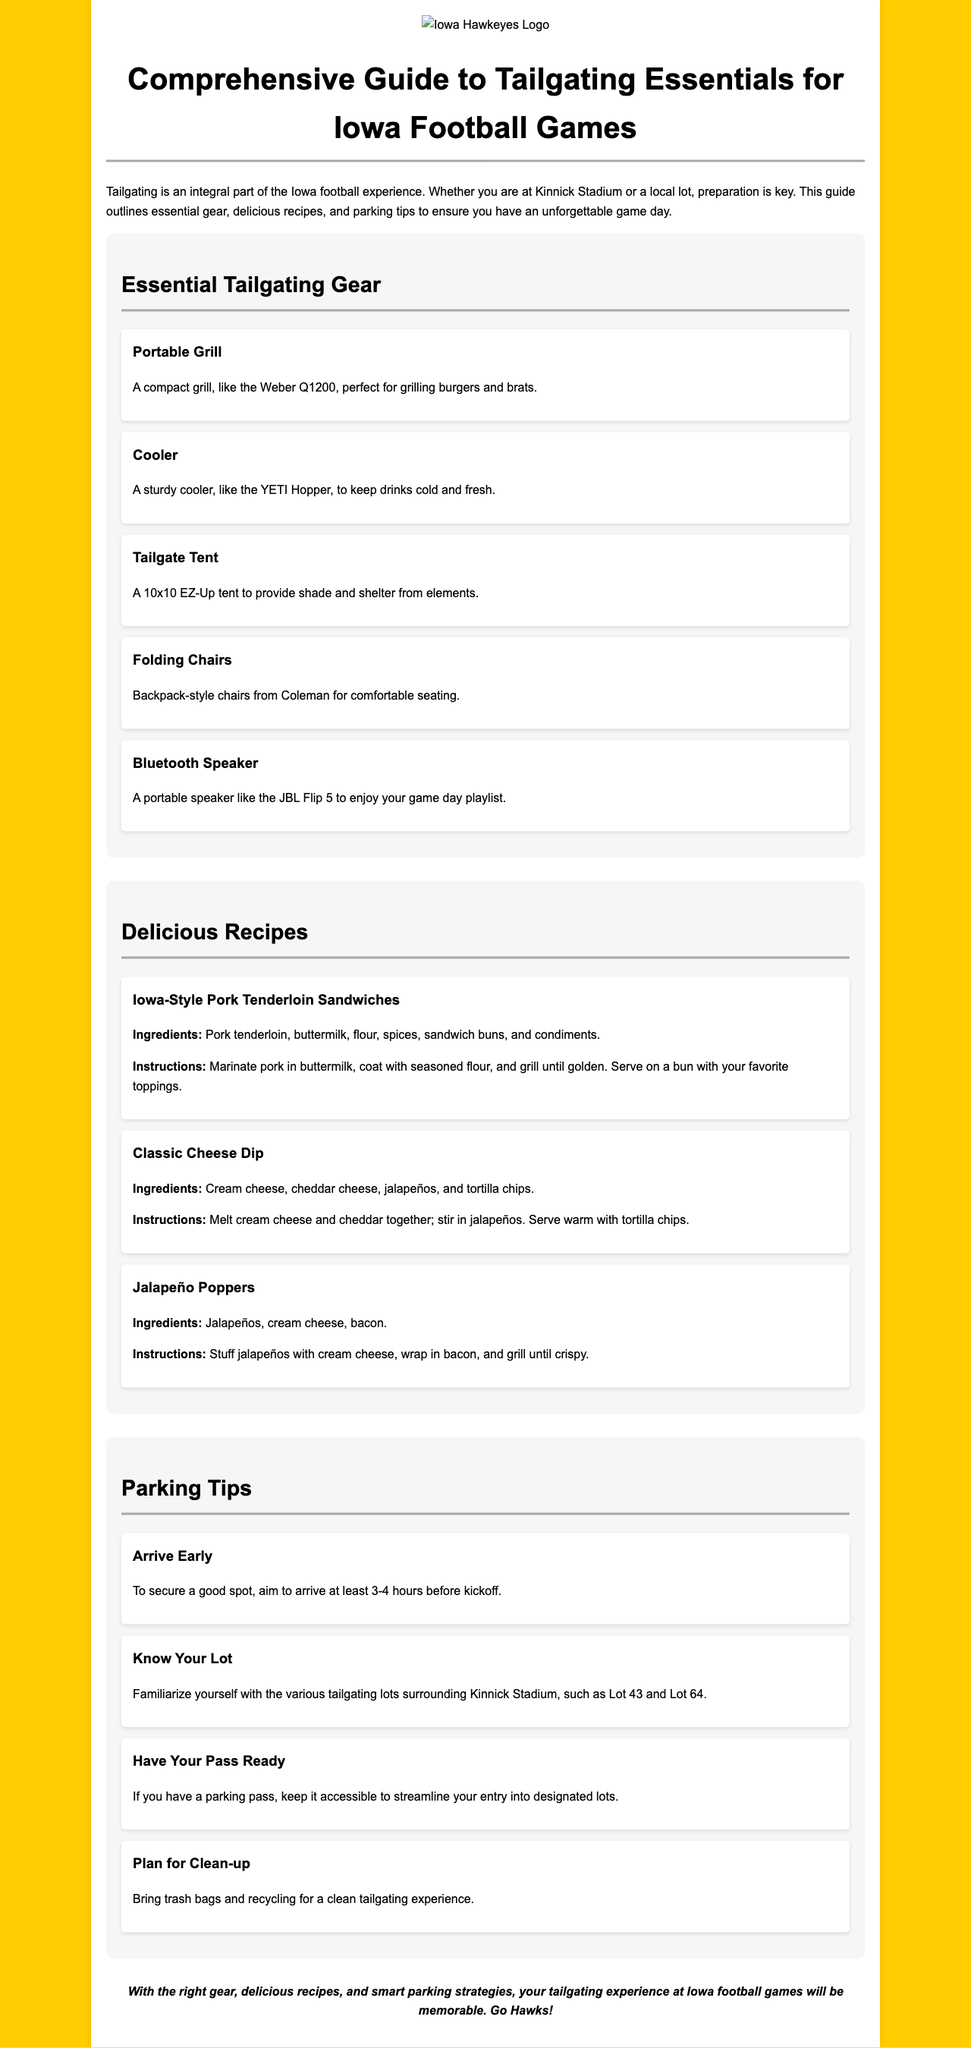What is the title of the document? The title is found in the header section of the document.
Answer: Comprehensive Guide to Tailgating Essentials for Iowa Football Games What are two essential tailgating gear items? This is based on the listed items under the essential tailgating gear section.
Answer: Portable Grill, Cooler What time should you arrive to secure a good parking spot? This information is stated in the parking tips section of the document.
Answer: 3-4 hours before kickoff What is one of the main ingredients in Iowa-Style Pork Tenderloin Sandwiches? The recipe section lists the ingredients for each dish.
Answer: Pork tenderloin Which lot is mentioned as a tailgating location? The document specifies certain lots near Kinnick Stadium in the parking tips section.
Answer: Lot 43 What type of chair is recommended for tailgating? The gear item section describes a specific style of chair.
Answer: Backpack-style chairs What should you bring for clean-up? This is indicated in the parking tips section about planning for clean-up.
Answer: Trash bags and recycling How is the document visually structured? The document employs sections, headings, and lists for organization.
Answer: Sectioned with headings What does the conclusion encourage? The conclusion summarizes the experience and enthusiasm for tailgating.
Answer: Memorable experience 